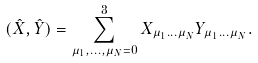<formula> <loc_0><loc_0><loc_500><loc_500>( \hat { X } , \hat { Y } ) = \sum _ { \mu _ { 1 } , \dots , \mu _ { N } = 0 } ^ { 3 } X _ { \mu _ { 1 } \dots \mu _ { N } } Y _ { \mu _ { 1 } \dots \mu _ { N } } .</formula> 